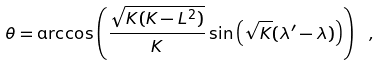<formula> <loc_0><loc_0><loc_500><loc_500>\theta = \arccos \left ( \frac { \sqrt { K ( K - L ^ { 2 } ) } } { K } \sin { \left ( \sqrt { K } ( \lambda ^ { \prime } - \lambda ) \right ) } \right ) \ ,</formula> 